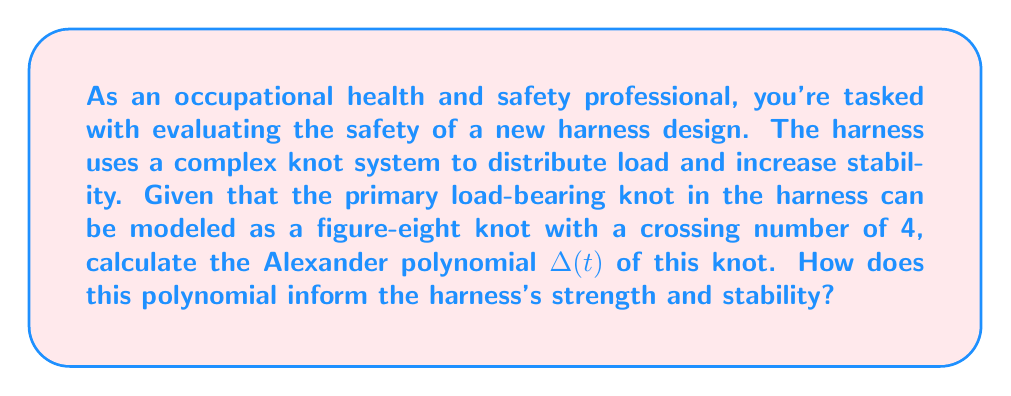Help me with this question. To assess the strength and stability of the safety harness using knot theory, we'll calculate the Alexander polynomial of the figure-eight knot and interpret its significance.

Step 1: Understand the figure-eight knot
The figure-eight knot is a prime knot with a crossing number of 4. It's the simplest non-trivial knot after the trefoil knot.

Step 2: Calculate the Alexander polynomial
For the figure-eight knot, the Alexander polynomial is:

$$\Delta(t) = t^2 - 3t + 1$$

To calculate this:
1. Create a knot diagram and assign orientations to each strand.
2. Label the regions of the diagram.
3. Construct the Alexander matrix using the crossing information.
4. Calculate the determinant of a submatrix to obtain the polynomial.

Step 3: Interpret the Alexander polynomial
The Alexander polynomial provides information about the knot's complexity:

1. Degree: The degree of the polynomial (2 in this case) relates to the knot's complexity. Higher degrees generally indicate more complex knots.

2. Coefficients: The coefficients (-3, 1, 1) give information about how the knot's strands interact. Larger coefficients often indicate more intricate strand interactions.

3. Symmetry: The polynomial is symmetric (reading the same forwards and backwards), which is a property of all Alexander polynomials.

Step 4: Relate to harness strength and stability
1. Complexity: The figure-eight knot, while simple, is more complex than a simple overhand knot. This added complexity can contribute to increased stability in the harness.

2. Load distribution: The symmetry of the polynomial suggests that the knot distributes load evenly, which is crucial for harness stability.

3. Resistance to slipping: The non-trivial nature of the polynomial (not just 1) indicates that the knot has some resistance to slipping, which is essential for harness safety.

4. Comparative analysis: By comparing this polynomial to those of other knots, we can assess relative strengths and choose the most suitable knot for the harness design.
Answer: The Alexander polynomial for the figure-eight knot used in the harness is $\Delta(t) = t^2 - 3t + 1$. This polynomial indicates a moderately complex knot with good load distribution and slip resistance, suggesting a stable and relatively strong configuration for the safety harness. However, further mechanical testing should be conducted to confirm these theoretical insights. 